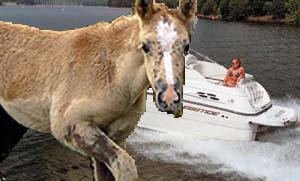What time of day does it seem to be in the image, and how can you tell? It appears to be daytime in the image, evident from the bright lighting and the clear visibility of the surroundings, which include the boat on the water and the horse in the foreground. The sunlight seems to enhance the vibrant colors of the scene, suggesting it's possibly midday or early afternoon. 